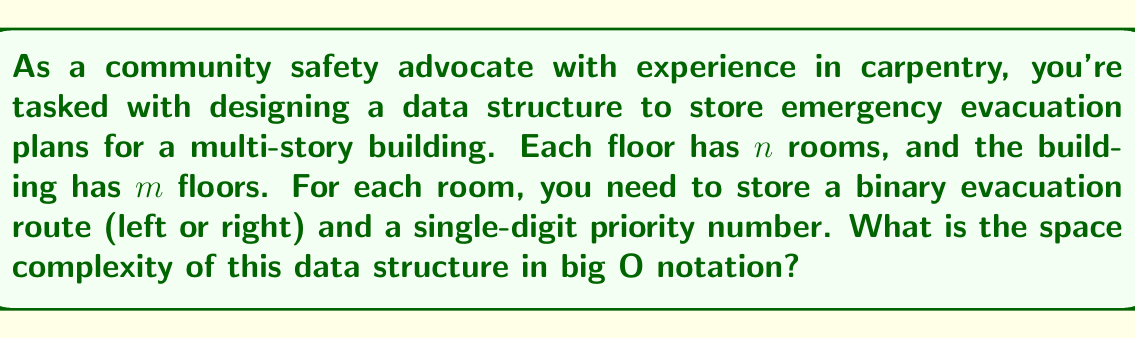Help me with this question. Let's break this down step-by-step:

1) For each room, we need to store two pieces of information:
   a) A binary evacuation route (left or right): This can be represented by a single bit.
   b) A single-digit priority number: This requires 4 bits (as $2^3 = 8 < 10 < 2^4 = 16$).

2) So, for each room, we need 1 + 4 = 5 bits of information.

3) There are $n$ rooms per floor, so each floor requires $5n$ bits.

4) The building has $m$ floors, so the total number of bits required is $5nm$.

5) In big O notation, we ignore constant factors. Therefore, the space complexity is $O(nm)$.

6) This can be interpreted as a 2D array or matrix, where each cell represents a room and contains 5 bits of information.

7) From a carpenter's perspective, this is analogous to creating a blueprint where each room is a cell in a grid, containing specific markings for evacuation routes and priorities.
Answer: The space complexity is $O(nm)$, where $n$ is the number of rooms per floor and $m$ is the number of floors. 